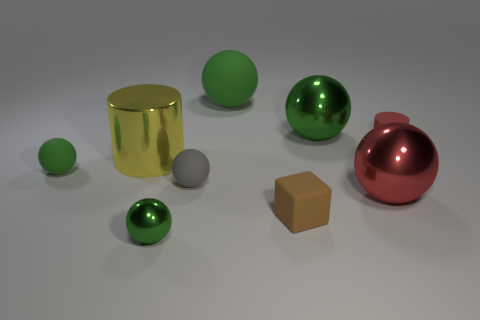Are there any tiny rubber things that are on the left side of the green rubber thing that is behind the green matte ball that is in front of the tiny cylinder?
Keep it short and to the point. Yes. What is the color of the big object that is the same material as the block?
Give a very brief answer. Green. What number of small green objects are the same material as the big yellow cylinder?
Your answer should be very brief. 1. Are the large yellow cylinder and the big ball in front of the yellow cylinder made of the same material?
Provide a succinct answer. Yes. What number of things are either large objects behind the tiny green rubber sphere or tiny rubber balls?
Keep it short and to the point. 5. There is a cylinder to the left of the metal sphere behind the large metal sphere that is in front of the red matte cylinder; what size is it?
Offer a terse response. Large. What material is the big object that is the same color as the big rubber sphere?
Offer a terse response. Metal. Is there any other thing that is the same shape as the brown object?
Give a very brief answer. No. There is a green metallic ball in front of the green matte thing that is in front of the red rubber object; how big is it?
Provide a short and direct response. Small. What number of small things are either blocks or shiny cylinders?
Provide a short and direct response. 1. 